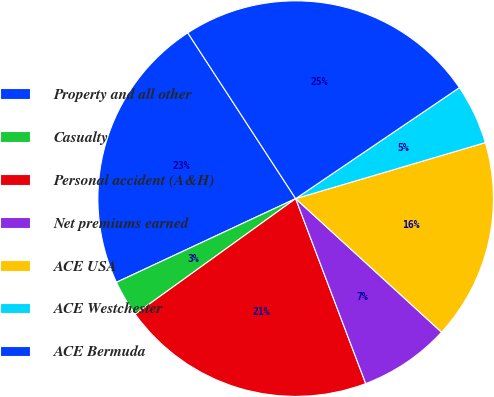Convert chart. <chart><loc_0><loc_0><loc_500><loc_500><pie_chart><fcel>Property and all other<fcel>Casualty<fcel>Personal accident (A&H)<fcel>Net premiums earned<fcel>ACE USA<fcel>ACE Westchester<fcel>ACE Bermuda<nl><fcel>22.77%<fcel>2.98%<fcel>20.83%<fcel>7.44%<fcel>16.37%<fcel>4.91%<fcel>24.7%<nl></chart> 